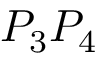<formula> <loc_0><loc_0><loc_500><loc_500>P _ { 3 } P _ { 4 }</formula> 